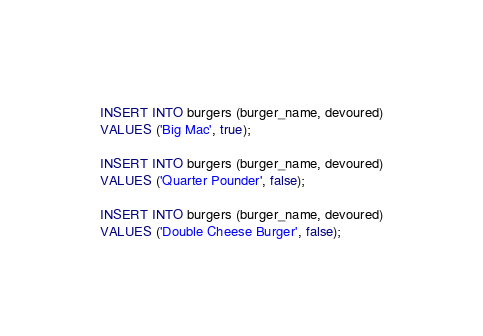Convert code to text. <code><loc_0><loc_0><loc_500><loc_500><_SQL_>INSERT INTO burgers (burger_name, devoured)
VALUES ('Big Mac', true);

INSERT INTO burgers (burger_name, devoured)
VALUES ('Quarter Pounder', false);

INSERT INTO burgers (burger_name, devoured)
VALUES ('Double Cheese Burger', false);</code> 